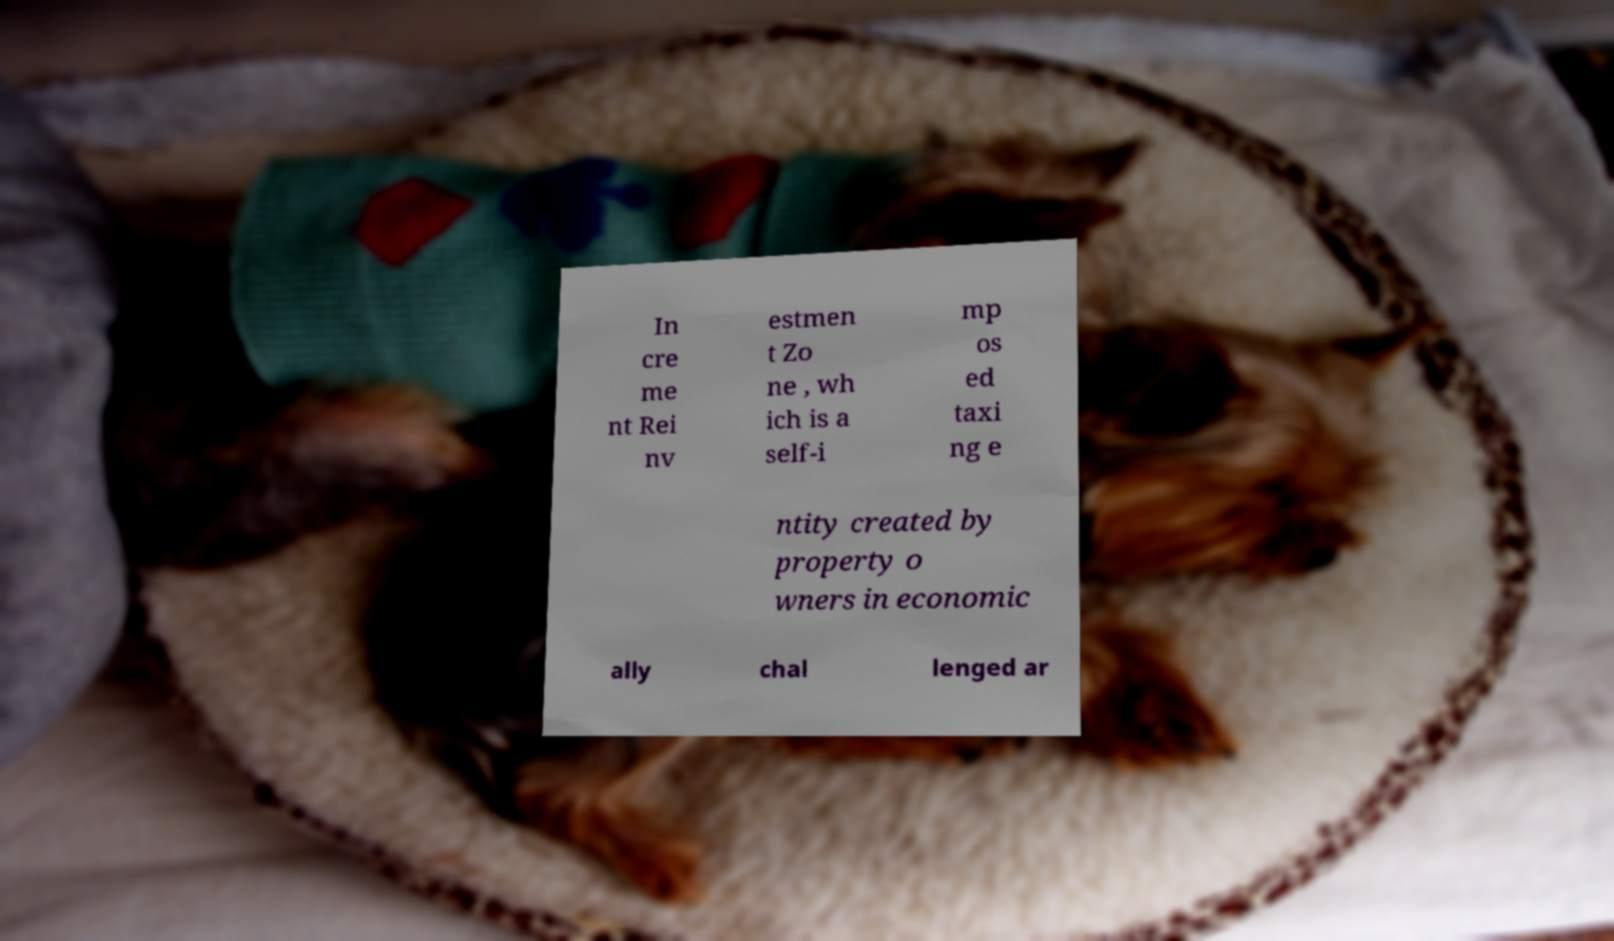I need the written content from this picture converted into text. Can you do that? In cre me nt Rei nv estmen t Zo ne , wh ich is a self-i mp os ed taxi ng e ntity created by property o wners in economic ally chal lenged ar 